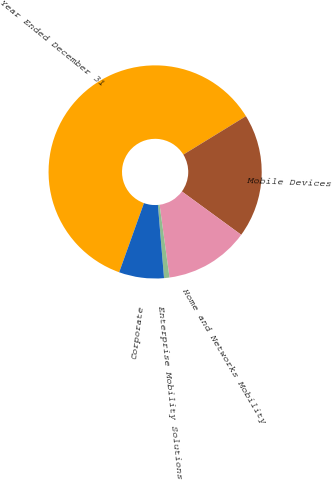Convert chart. <chart><loc_0><loc_0><loc_500><loc_500><pie_chart><fcel>Year Ended December 31<fcel>Mobile Devices<fcel>Home and Networks Mobility<fcel>Enterprise Mobility Solutions<fcel>Corporate<nl><fcel>60.76%<fcel>18.8%<fcel>12.81%<fcel>0.82%<fcel>6.81%<nl></chart> 